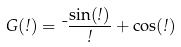Convert formula to latex. <formula><loc_0><loc_0><loc_500><loc_500>G ( \omega ) = \mu \frac { \sin ( \omega ) } { \omega } + \cos ( \omega )</formula> 